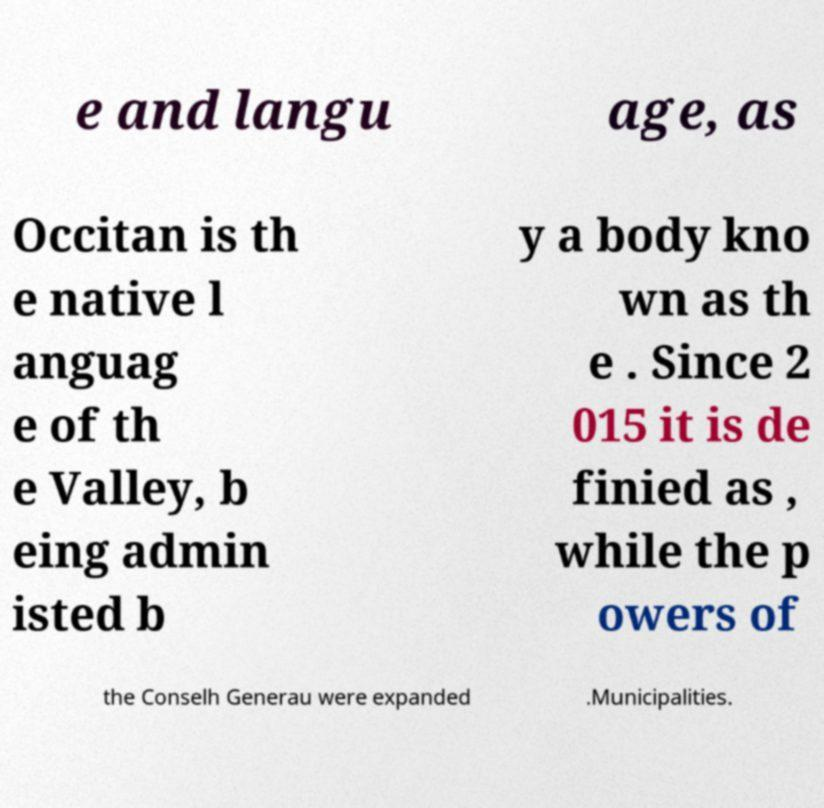Please identify and transcribe the text found in this image. e and langu age, as Occitan is th e native l anguag e of th e Valley, b eing admin isted b y a body kno wn as th e . Since 2 015 it is de finied as , while the p owers of the Conselh Generau were expanded .Municipalities. 